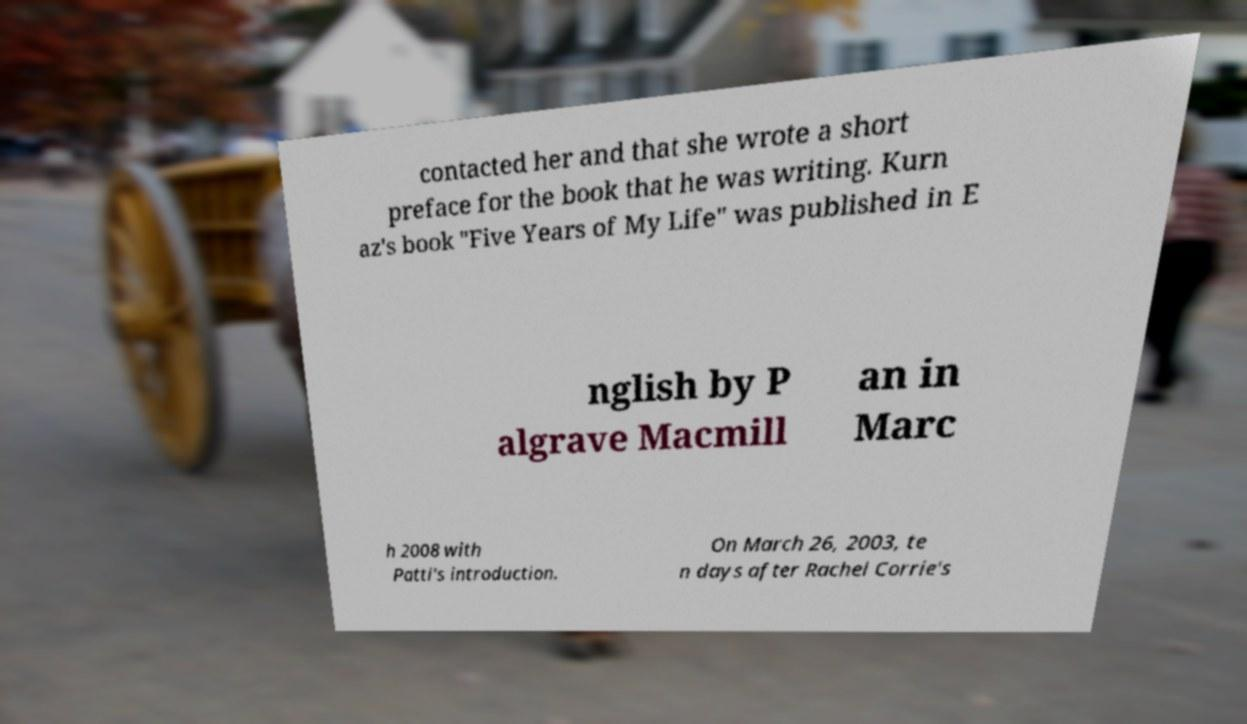For documentation purposes, I need the text within this image transcribed. Could you provide that? contacted her and that she wrote a short preface for the book that he was writing. Kurn az's book "Five Years of My Life" was published in E nglish by P algrave Macmill an in Marc h 2008 with Patti's introduction. On March 26, 2003, te n days after Rachel Corrie's 